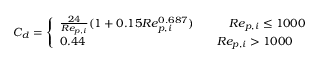Convert formula to latex. <formula><loc_0><loc_0><loc_500><loc_500>C _ { d } = \left \{ \begin{array} { l l } { \frac { 2 4 } { R e _ { p , i } } ( 1 + 0 . 1 5 R e _ { p , i } ^ { 0 . 6 8 7 } ) \quad R e _ { p , i } \leq 1 0 0 0 } \\ { 0 . 4 4 \quad R e _ { p , i } > 1 0 0 0 } \end{array}</formula> 